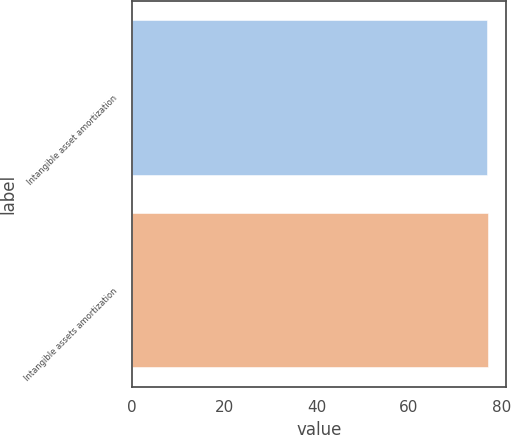<chart> <loc_0><loc_0><loc_500><loc_500><bar_chart><fcel>Intangible asset amortization<fcel>Intangible assets amortization<nl><fcel>77<fcel>77.1<nl></chart> 